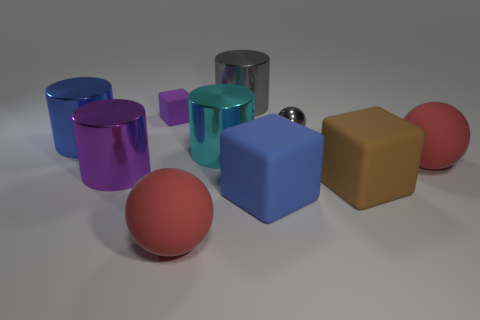What number of objects are large matte spheres left of the tiny gray sphere or blue objects?
Provide a succinct answer. 3. Does the cube behind the tiny gray ball have the same color as the metal ball?
Provide a succinct answer. No. How many other things are the same color as the small sphere?
Keep it short and to the point. 1. How many large things are either gray objects or purple matte blocks?
Offer a very short reply. 1. Is the number of small cyan balls greater than the number of tiny purple rubber objects?
Provide a short and direct response. No. Is the material of the tiny gray ball the same as the big cyan thing?
Make the answer very short. Yes. Is there any other thing that is the same material as the large purple thing?
Your response must be concise. Yes. Are there more gray balls right of the large blue rubber thing than large purple things?
Keep it short and to the point. No. Do the tiny shiny object and the small rubber block have the same color?
Offer a very short reply. No. How many other small things are the same shape as the small purple rubber thing?
Keep it short and to the point. 0. 